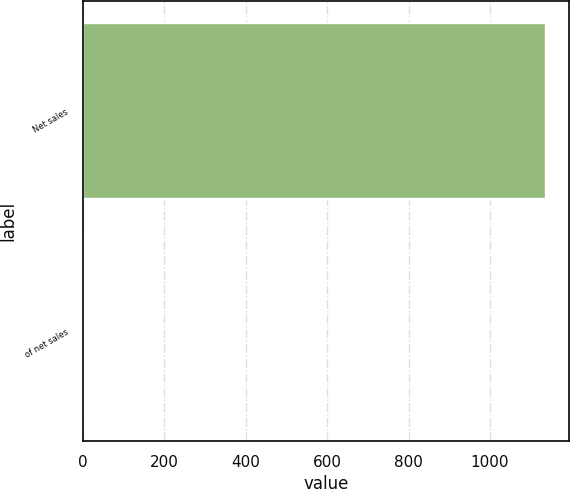<chart> <loc_0><loc_0><loc_500><loc_500><bar_chart><fcel>Net sales<fcel>of net sales<nl><fcel>1136.7<fcel>3.1<nl></chart> 